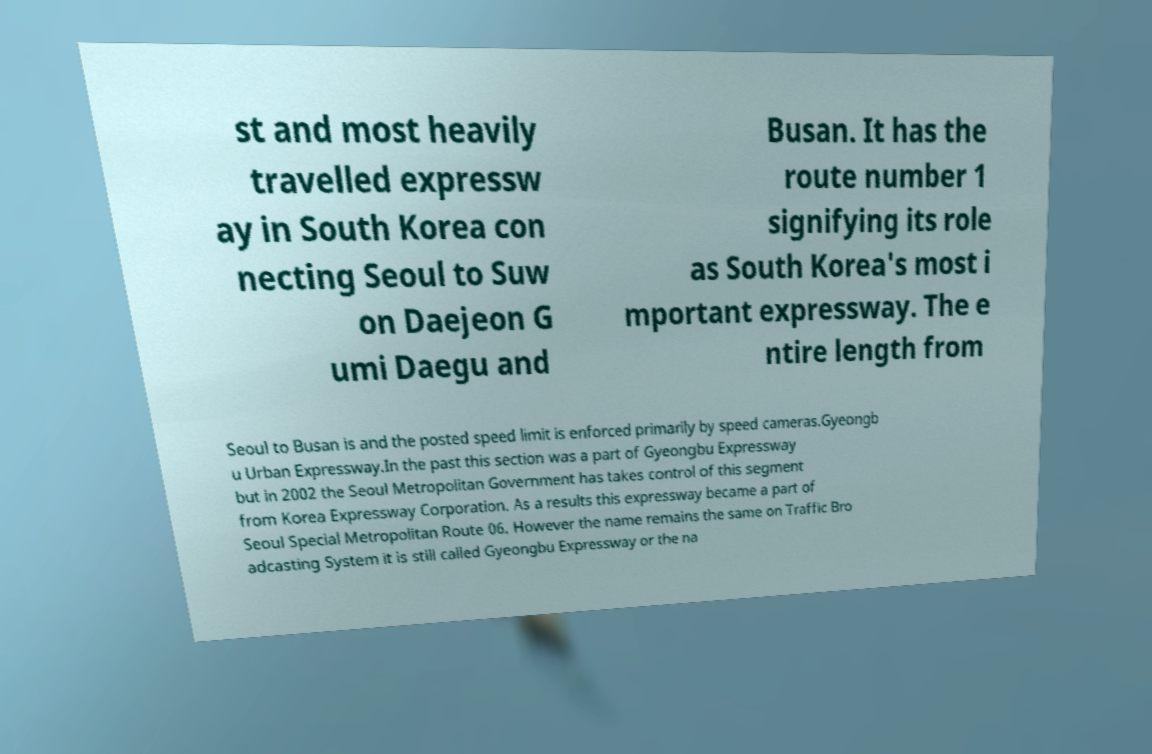What messages or text are displayed in this image? I need them in a readable, typed format. st and most heavily travelled expressw ay in South Korea con necting Seoul to Suw on Daejeon G umi Daegu and Busan. It has the route number 1 signifying its role as South Korea's most i mportant expressway. The e ntire length from Seoul to Busan is and the posted speed limit is enforced primarily by speed cameras.Gyeongb u Urban Expressway.In the past this section was a part of Gyeongbu Expressway but in 2002 the Seoul Metropolitan Government has takes control of this segment from Korea Expressway Corporation. As a results this expressway became a part of Seoul Special Metropolitan Route 06. However the name remains the same on Traffic Bro adcasting System it is still called Gyeongbu Expressway or the na 